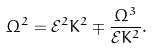Convert formula to latex. <formula><loc_0><loc_0><loc_500><loc_500>\Omega ^ { 2 } = \mathcal { E } ^ { 2 } K ^ { 2 } \mp \frac { \Omega ^ { 3 } } { \mathcal { E } K ^ { 2 } } .</formula> 